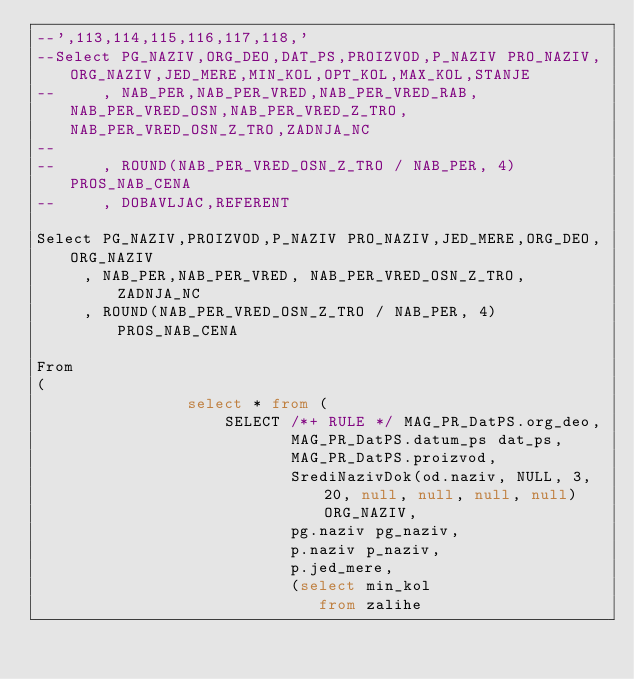Convert code to text. <code><loc_0><loc_0><loc_500><loc_500><_SQL_>--',113,114,115,116,117,118,'
--Select PG_NAZIV,ORG_DEO,DAT_PS,PROIZVOD,P_NAZIV PRO_NAZIV,ORG_NAZIV,JED_MERE,MIN_KOL,OPT_KOL,MAX_KOL,STANJE
--     , NAB_PER,NAB_PER_VRED,NAB_PER_VRED_RAB,NAB_PER_VRED_OSN,NAB_PER_VRED_Z_TRO,NAB_PER_VRED_OSN_Z_TRO,ZADNJA_NC
--
--     , ROUND(NAB_PER_VRED_OSN_Z_TRO / NAB_PER, 4) PROS_NAB_CENA
--     , DOBAVLJAC,REFERENT

Select PG_NAZIV,PROIZVOD,P_NAZIV PRO_NAZIV,JED_MERE,ORG_DEO,ORG_NAZIV
     , NAB_PER,NAB_PER_VRED, NAB_PER_VRED_OSN_Z_TRO,ZADNJA_NC
     , ROUND(NAB_PER_VRED_OSN_Z_TRO / NAB_PER, 4) PROS_NAB_CENA

From
(
                select * from (
                    SELECT /*+ RULE */ MAG_PR_DatPS.org_deo,
                           MAG_PR_DatPS.datum_ps dat_ps,
                           MAG_PR_DatPS.proizvod,
                           SrediNazivDok(od.naziv, NULL, 3, 20, null, null, null, null) ORG_NAZIV,
                           pg.naziv pg_naziv,
                           p.naziv p_naziv,
                           p.jed_mere,
                           (select min_kol
                              from zalihe</code> 